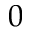<formula> <loc_0><loc_0><loc_500><loc_500>0</formula> 